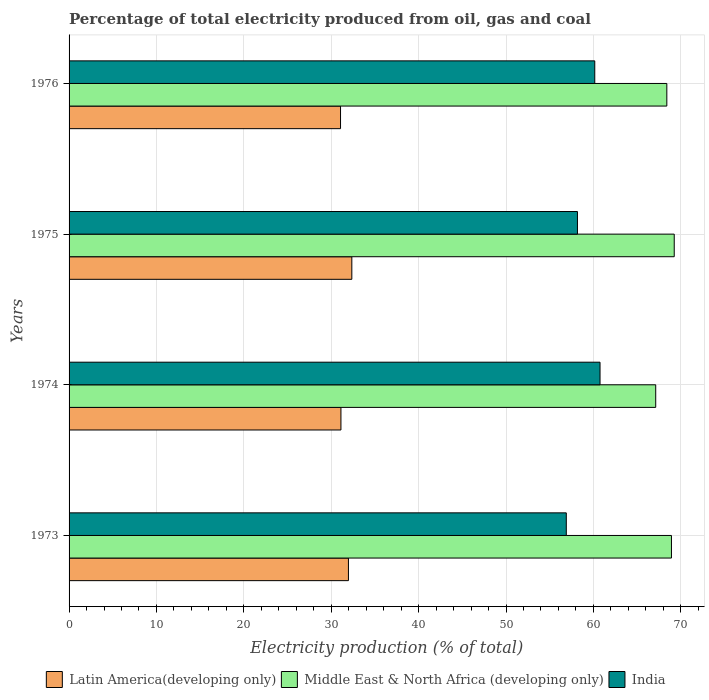How many different coloured bars are there?
Provide a short and direct response. 3. How many groups of bars are there?
Provide a short and direct response. 4. Are the number of bars on each tick of the Y-axis equal?
Your response must be concise. Yes. What is the label of the 3rd group of bars from the top?
Make the answer very short. 1974. What is the electricity production in in Latin America(developing only) in 1975?
Provide a succinct answer. 32.36. Across all years, what is the maximum electricity production in in India?
Offer a very short reply. 60.76. Across all years, what is the minimum electricity production in in Middle East & North Africa (developing only)?
Offer a terse response. 67.13. In which year was the electricity production in in Middle East & North Africa (developing only) maximum?
Provide a short and direct response. 1975. What is the total electricity production in in Latin America(developing only) in the graph?
Keep it short and to the point. 126.5. What is the difference between the electricity production in in Middle East & North Africa (developing only) in 1974 and that in 1976?
Give a very brief answer. -1.27. What is the difference between the electricity production in in India in 1973 and the electricity production in in Middle East & North Africa (developing only) in 1976?
Offer a very short reply. -11.5. What is the average electricity production in in India per year?
Your response must be concise. 59. In the year 1975, what is the difference between the electricity production in in Latin America(developing only) and electricity production in in India?
Keep it short and to the point. -25.82. What is the ratio of the electricity production in in Latin America(developing only) in 1974 to that in 1976?
Give a very brief answer. 1. What is the difference between the highest and the second highest electricity production in in Middle East & North Africa (developing only)?
Your answer should be compact. 0.32. What is the difference between the highest and the lowest electricity production in in India?
Provide a succinct answer. 3.86. In how many years, is the electricity production in in Latin America(developing only) greater than the average electricity production in in Latin America(developing only) taken over all years?
Your response must be concise. 2. What does the 2nd bar from the top in 1974 represents?
Provide a succinct answer. Middle East & North Africa (developing only). Is it the case that in every year, the sum of the electricity production in in Middle East & North Africa (developing only) and electricity production in in Latin America(developing only) is greater than the electricity production in in India?
Your response must be concise. Yes. How many bars are there?
Your response must be concise. 12. Are all the bars in the graph horizontal?
Give a very brief answer. Yes. How many years are there in the graph?
Your response must be concise. 4. What is the difference between two consecutive major ticks on the X-axis?
Your answer should be compact. 10. Does the graph contain any zero values?
Offer a terse response. No. Does the graph contain grids?
Offer a very short reply. Yes. How are the legend labels stacked?
Ensure brevity in your answer.  Horizontal. What is the title of the graph?
Your response must be concise. Percentage of total electricity produced from oil, gas and coal. What is the label or title of the X-axis?
Ensure brevity in your answer.  Electricity production (% of total). What is the Electricity production (% of total) in Latin America(developing only) in 1973?
Provide a succinct answer. 31.97. What is the Electricity production (% of total) of Middle East & North Africa (developing only) in 1973?
Offer a terse response. 68.93. What is the Electricity production (% of total) of India in 1973?
Your response must be concise. 56.9. What is the Electricity production (% of total) of Latin America(developing only) in 1974?
Offer a very short reply. 31.11. What is the Electricity production (% of total) of Middle East & North Africa (developing only) in 1974?
Give a very brief answer. 67.13. What is the Electricity production (% of total) of India in 1974?
Make the answer very short. 60.76. What is the Electricity production (% of total) of Latin America(developing only) in 1975?
Offer a very short reply. 32.36. What is the Electricity production (% of total) of Middle East & North Africa (developing only) in 1975?
Provide a short and direct response. 69.25. What is the Electricity production (% of total) of India in 1975?
Ensure brevity in your answer.  58.18. What is the Electricity production (% of total) in Latin America(developing only) in 1976?
Provide a succinct answer. 31.06. What is the Electricity production (% of total) of Middle East & North Africa (developing only) in 1976?
Give a very brief answer. 68.4. What is the Electricity production (% of total) in India in 1976?
Ensure brevity in your answer.  60.16. Across all years, what is the maximum Electricity production (% of total) in Latin America(developing only)?
Ensure brevity in your answer.  32.36. Across all years, what is the maximum Electricity production (% of total) in Middle East & North Africa (developing only)?
Your answer should be very brief. 69.25. Across all years, what is the maximum Electricity production (% of total) of India?
Give a very brief answer. 60.76. Across all years, what is the minimum Electricity production (% of total) of Latin America(developing only)?
Offer a very short reply. 31.06. Across all years, what is the minimum Electricity production (% of total) in Middle East & North Africa (developing only)?
Ensure brevity in your answer.  67.13. Across all years, what is the minimum Electricity production (% of total) in India?
Make the answer very short. 56.9. What is the total Electricity production (% of total) in Latin America(developing only) in the graph?
Offer a very short reply. 126.5. What is the total Electricity production (% of total) of Middle East & North Africa (developing only) in the graph?
Offer a very short reply. 273.72. What is the total Electricity production (% of total) of India in the graph?
Your answer should be compact. 235.99. What is the difference between the Electricity production (% of total) of Latin America(developing only) in 1973 and that in 1974?
Your response must be concise. 0.86. What is the difference between the Electricity production (% of total) in Middle East & North Africa (developing only) in 1973 and that in 1974?
Your answer should be compact. 1.8. What is the difference between the Electricity production (% of total) in India in 1973 and that in 1974?
Offer a very short reply. -3.86. What is the difference between the Electricity production (% of total) of Latin America(developing only) in 1973 and that in 1975?
Offer a very short reply. -0.39. What is the difference between the Electricity production (% of total) of Middle East & North Africa (developing only) in 1973 and that in 1975?
Your response must be concise. -0.32. What is the difference between the Electricity production (% of total) in India in 1973 and that in 1975?
Give a very brief answer. -1.28. What is the difference between the Electricity production (% of total) in Latin America(developing only) in 1973 and that in 1976?
Your response must be concise. 0.91. What is the difference between the Electricity production (% of total) in Middle East & North Africa (developing only) in 1973 and that in 1976?
Give a very brief answer. 0.53. What is the difference between the Electricity production (% of total) in India in 1973 and that in 1976?
Your answer should be compact. -3.26. What is the difference between the Electricity production (% of total) in Latin America(developing only) in 1974 and that in 1975?
Provide a succinct answer. -1.25. What is the difference between the Electricity production (% of total) in Middle East & North Africa (developing only) in 1974 and that in 1975?
Your answer should be compact. -2.12. What is the difference between the Electricity production (% of total) in India in 1974 and that in 1975?
Give a very brief answer. 2.58. What is the difference between the Electricity production (% of total) in Latin America(developing only) in 1974 and that in 1976?
Your response must be concise. 0.05. What is the difference between the Electricity production (% of total) of Middle East & North Africa (developing only) in 1974 and that in 1976?
Offer a very short reply. -1.27. What is the difference between the Electricity production (% of total) in India in 1974 and that in 1976?
Provide a succinct answer. 0.6. What is the difference between the Electricity production (% of total) of Latin America(developing only) in 1975 and that in 1976?
Offer a very short reply. 1.29. What is the difference between the Electricity production (% of total) of Middle East & North Africa (developing only) in 1975 and that in 1976?
Your answer should be compact. 0.85. What is the difference between the Electricity production (% of total) of India in 1975 and that in 1976?
Keep it short and to the point. -1.98. What is the difference between the Electricity production (% of total) of Latin America(developing only) in 1973 and the Electricity production (% of total) of Middle East & North Africa (developing only) in 1974?
Keep it short and to the point. -35.16. What is the difference between the Electricity production (% of total) in Latin America(developing only) in 1973 and the Electricity production (% of total) in India in 1974?
Offer a very short reply. -28.79. What is the difference between the Electricity production (% of total) in Middle East & North Africa (developing only) in 1973 and the Electricity production (% of total) in India in 1974?
Offer a very short reply. 8.17. What is the difference between the Electricity production (% of total) of Latin America(developing only) in 1973 and the Electricity production (% of total) of Middle East & North Africa (developing only) in 1975?
Provide a succinct answer. -37.28. What is the difference between the Electricity production (% of total) of Latin America(developing only) in 1973 and the Electricity production (% of total) of India in 1975?
Your answer should be compact. -26.21. What is the difference between the Electricity production (% of total) in Middle East & North Africa (developing only) in 1973 and the Electricity production (% of total) in India in 1975?
Make the answer very short. 10.76. What is the difference between the Electricity production (% of total) in Latin America(developing only) in 1973 and the Electricity production (% of total) in Middle East & North Africa (developing only) in 1976?
Provide a short and direct response. -36.43. What is the difference between the Electricity production (% of total) of Latin America(developing only) in 1973 and the Electricity production (% of total) of India in 1976?
Provide a succinct answer. -28.19. What is the difference between the Electricity production (% of total) in Middle East & North Africa (developing only) in 1973 and the Electricity production (% of total) in India in 1976?
Provide a short and direct response. 8.78. What is the difference between the Electricity production (% of total) in Latin America(developing only) in 1974 and the Electricity production (% of total) in Middle East & North Africa (developing only) in 1975?
Provide a succinct answer. -38.14. What is the difference between the Electricity production (% of total) in Latin America(developing only) in 1974 and the Electricity production (% of total) in India in 1975?
Your answer should be compact. -27.07. What is the difference between the Electricity production (% of total) of Middle East & North Africa (developing only) in 1974 and the Electricity production (% of total) of India in 1975?
Offer a very short reply. 8.96. What is the difference between the Electricity production (% of total) of Latin America(developing only) in 1974 and the Electricity production (% of total) of Middle East & North Africa (developing only) in 1976?
Provide a succinct answer. -37.29. What is the difference between the Electricity production (% of total) of Latin America(developing only) in 1974 and the Electricity production (% of total) of India in 1976?
Offer a terse response. -29.05. What is the difference between the Electricity production (% of total) in Middle East & North Africa (developing only) in 1974 and the Electricity production (% of total) in India in 1976?
Offer a terse response. 6.98. What is the difference between the Electricity production (% of total) of Latin America(developing only) in 1975 and the Electricity production (% of total) of Middle East & North Africa (developing only) in 1976?
Provide a succinct answer. -36.05. What is the difference between the Electricity production (% of total) in Latin America(developing only) in 1975 and the Electricity production (% of total) in India in 1976?
Offer a terse response. -27.8. What is the difference between the Electricity production (% of total) in Middle East & North Africa (developing only) in 1975 and the Electricity production (% of total) in India in 1976?
Your response must be concise. 9.09. What is the average Electricity production (% of total) in Latin America(developing only) per year?
Ensure brevity in your answer.  31.63. What is the average Electricity production (% of total) of Middle East & North Africa (developing only) per year?
Your answer should be very brief. 68.43. What is the average Electricity production (% of total) of India per year?
Keep it short and to the point. 59. In the year 1973, what is the difference between the Electricity production (% of total) in Latin America(developing only) and Electricity production (% of total) in Middle East & North Africa (developing only)?
Offer a very short reply. -36.96. In the year 1973, what is the difference between the Electricity production (% of total) in Latin America(developing only) and Electricity production (% of total) in India?
Your response must be concise. -24.93. In the year 1973, what is the difference between the Electricity production (% of total) in Middle East & North Africa (developing only) and Electricity production (% of total) in India?
Ensure brevity in your answer.  12.03. In the year 1974, what is the difference between the Electricity production (% of total) of Latin America(developing only) and Electricity production (% of total) of Middle East & North Africa (developing only)?
Your answer should be very brief. -36.02. In the year 1974, what is the difference between the Electricity production (% of total) in Latin America(developing only) and Electricity production (% of total) in India?
Your answer should be very brief. -29.65. In the year 1974, what is the difference between the Electricity production (% of total) of Middle East & North Africa (developing only) and Electricity production (% of total) of India?
Give a very brief answer. 6.37. In the year 1975, what is the difference between the Electricity production (% of total) in Latin America(developing only) and Electricity production (% of total) in Middle East & North Africa (developing only)?
Offer a terse response. -36.89. In the year 1975, what is the difference between the Electricity production (% of total) in Latin America(developing only) and Electricity production (% of total) in India?
Make the answer very short. -25.82. In the year 1975, what is the difference between the Electricity production (% of total) in Middle East & North Africa (developing only) and Electricity production (% of total) in India?
Offer a very short reply. 11.07. In the year 1976, what is the difference between the Electricity production (% of total) in Latin America(developing only) and Electricity production (% of total) in Middle East & North Africa (developing only)?
Offer a terse response. -37.34. In the year 1976, what is the difference between the Electricity production (% of total) of Latin America(developing only) and Electricity production (% of total) of India?
Your answer should be compact. -29.09. In the year 1976, what is the difference between the Electricity production (% of total) of Middle East & North Africa (developing only) and Electricity production (% of total) of India?
Ensure brevity in your answer.  8.25. What is the ratio of the Electricity production (% of total) of Latin America(developing only) in 1973 to that in 1974?
Offer a terse response. 1.03. What is the ratio of the Electricity production (% of total) of Middle East & North Africa (developing only) in 1973 to that in 1974?
Give a very brief answer. 1.03. What is the ratio of the Electricity production (% of total) of India in 1973 to that in 1974?
Provide a succinct answer. 0.94. What is the ratio of the Electricity production (% of total) in Latin America(developing only) in 1973 to that in 1975?
Keep it short and to the point. 0.99. What is the ratio of the Electricity production (% of total) of Middle East & North Africa (developing only) in 1973 to that in 1975?
Your answer should be very brief. 1. What is the ratio of the Electricity production (% of total) of India in 1973 to that in 1975?
Ensure brevity in your answer.  0.98. What is the ratio of the Electricity production (% of total) of Latin America(developing only) in 1973 to that in 1976?
Ensure brevity in your answer.  1.03. What is the ratio of the Electricity production (% of total) of Middle East & North Africa (developing only) in 1973 to that in 1976?
Your response must be concise. 1.01. What is the ratio of the Electricity production (% of total) of India in 1973 to that in 1976?
Give a very brief answer. 0.95. What is the ratio of the Electricity production (% of total) in Latin America(developing only) in 1974 to that in 1975?
Offer a terse response. 0.96. What is the ratio of the Electricity production (% of total) of Middle East & North Africa (developing only) in 1974 to that in 1975?
Offer a terse response. 0.97. What is the ratio of the Electricity production (% of total) in India in 1974 to that in 1975?
Your answer should be very brief. 1.04. What is the ratio of the Electricity production (% of total) of Latin America(developing only) in 1974 to that in 1976?
Offer a very short reply. 1. What is the ratio of the Electricity production (% of total) of Middle East & North Africa (developing only) in 1974 to that in 1976?
Ensure brevity in your answer.  0.98. What is the ratio of the Electricity production (% of total) in India in 1974 to that in 1976?
Keep it short and to the point. 1.01. What is the ratio of the Electricity production (% of total) in Latin America(developing only) in 1975 to that in 1976?
Ensure brevity in your answer.  1.04. What is the ratio of the Electricity production (% of total) of Middle East & North Africa (developing only) in 1975 to that in 1976?
Ensure brevity in your answer.  1.01. What is the ratio of the Electricity production (% of total) in India in 1975 to that in 1976?
Your answer should be very brief. 0.97. What is the difference between the highest and the second highest Electricity production (% of total) in Latin America(developing only)?
Offer a terse response. 0.39. What is the difference between the highest and the second highest Electricity production (% of total) of Middle East & North Africa (developing only)?
Give a very brief answer. 0.32. What is the difference between the highest and the second highest Electricity production (% of total) of India?
Keep it short and to the point. 0.6. What is the difference between the highest and the lowest Electricity production (% of total) in Latin America(developing only)?
Keep it short and to the point. 1.29. What is the difference between the highest and the lowest Electricity production (% of total) of Middle East & North Africa (developing only)?
Provide a short and direct response. 2.12. What is the difference between the highest and the lowest Electricity production (% of total) in India?
Keep it short and to the point. 3.86. 